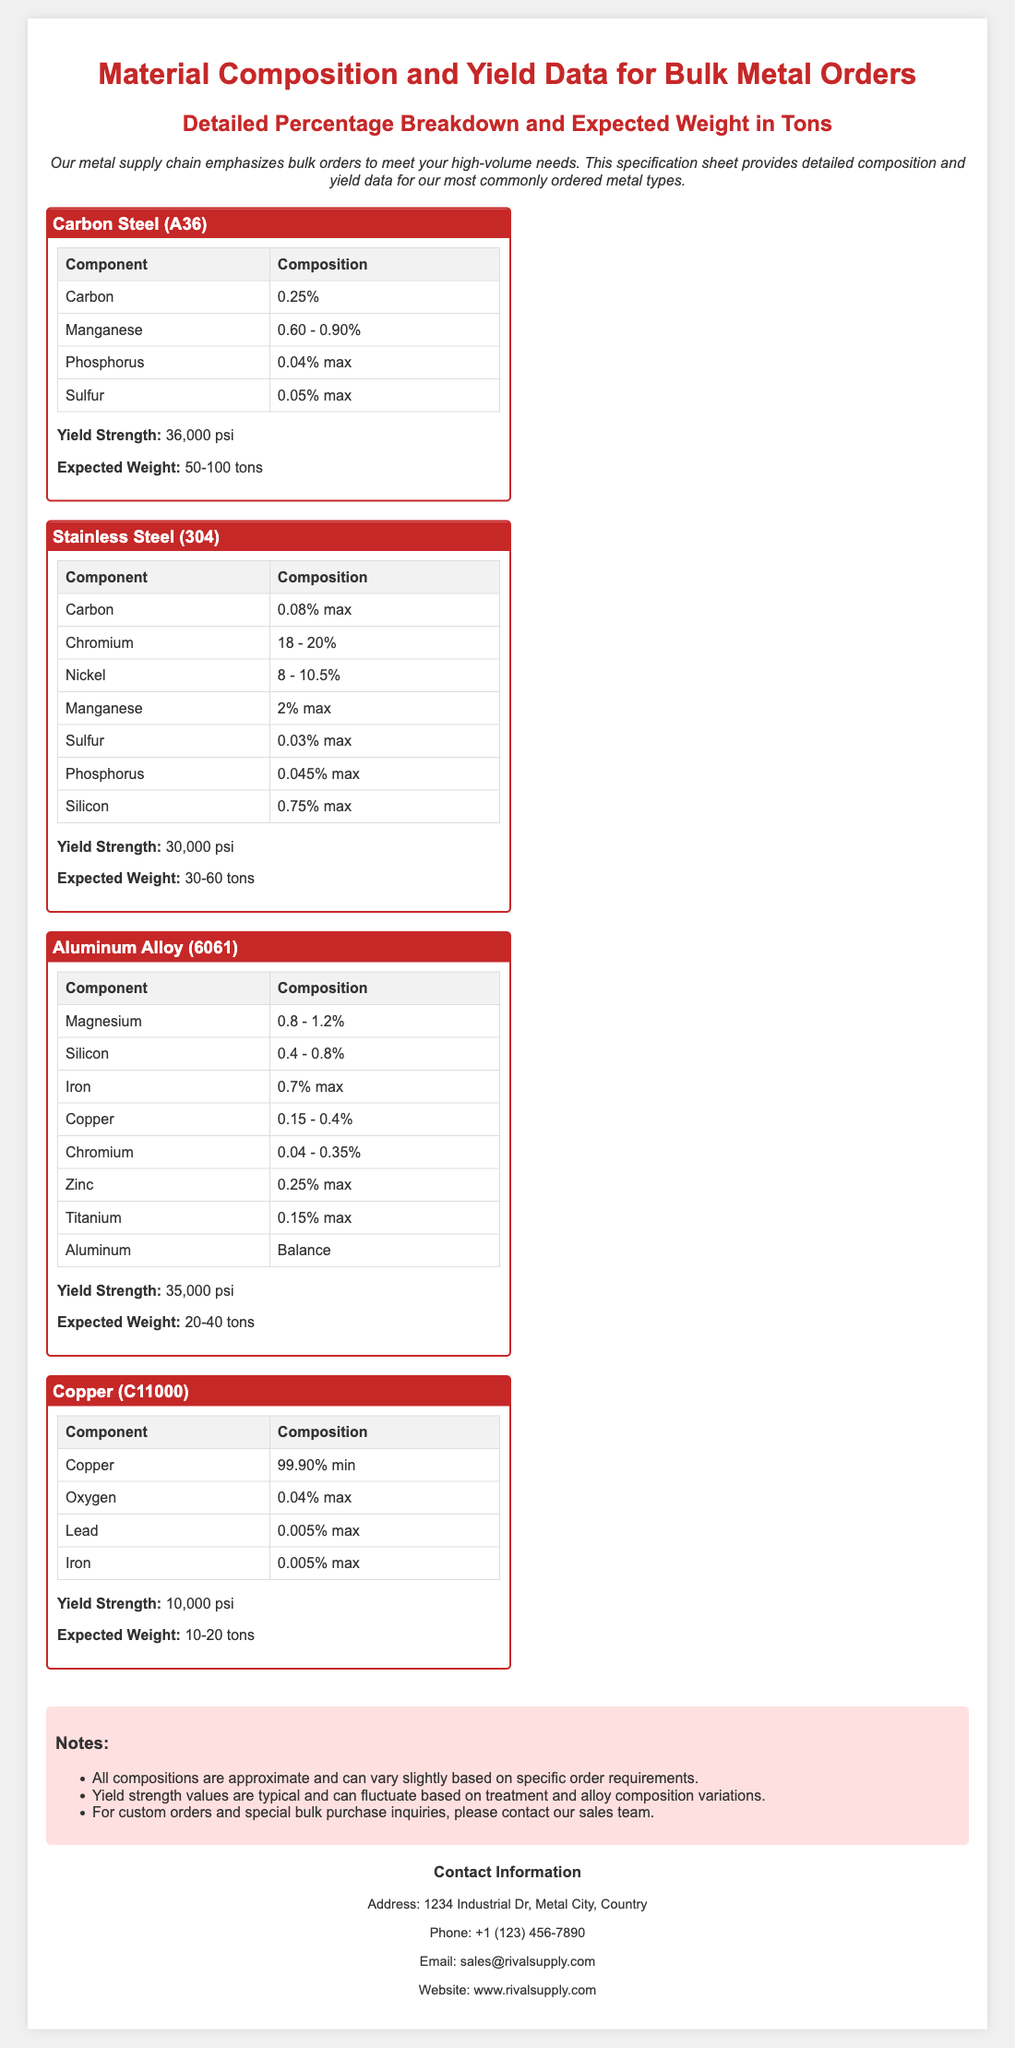What is the yield strength of Carbon Steel (A36)? The yield strength of Carbon Steel (A36) is stated in the specification sheet.
Answer: 36,000 psi What is the expected weight range for Stainless Steel (304) orders? The expected weight range is clearly indicated in the details of Stainless Steel (304).
Answer: 30-60 tons What is the maximum percentage composition of Sulfur in Aluminum Alloy (6061)? The specification provides the maximum composition for Sulfur in Aluminum Alloy (6061).
Answer: 0.25% max Which component has the highest minimum percentage in Copper (C11000)? The document lists the component percentages, indicating the highest minimum percentage.
Answer: 99.90% min What type of metal is specified for a yield strength of 10,000 psi? By reviewing the yield strengths, one can determine the metal type corresponding to 10,000 psi.
Answer: Copper (C11000) What is the composition range for Manganese in Carbon Steel (A36)? The document contains multiple component compositions, including that of Manganese.
Answer: 0.60 - 0.90% How many different metal types are listed in the document? By counting the metal types presented, we can determine the number of listings in the document.
Answer: 4 What is the main purpose of this specification sheet? The introduction section clearly states the purpose of this specification sheet.
Answer: Meet high-volume needs 